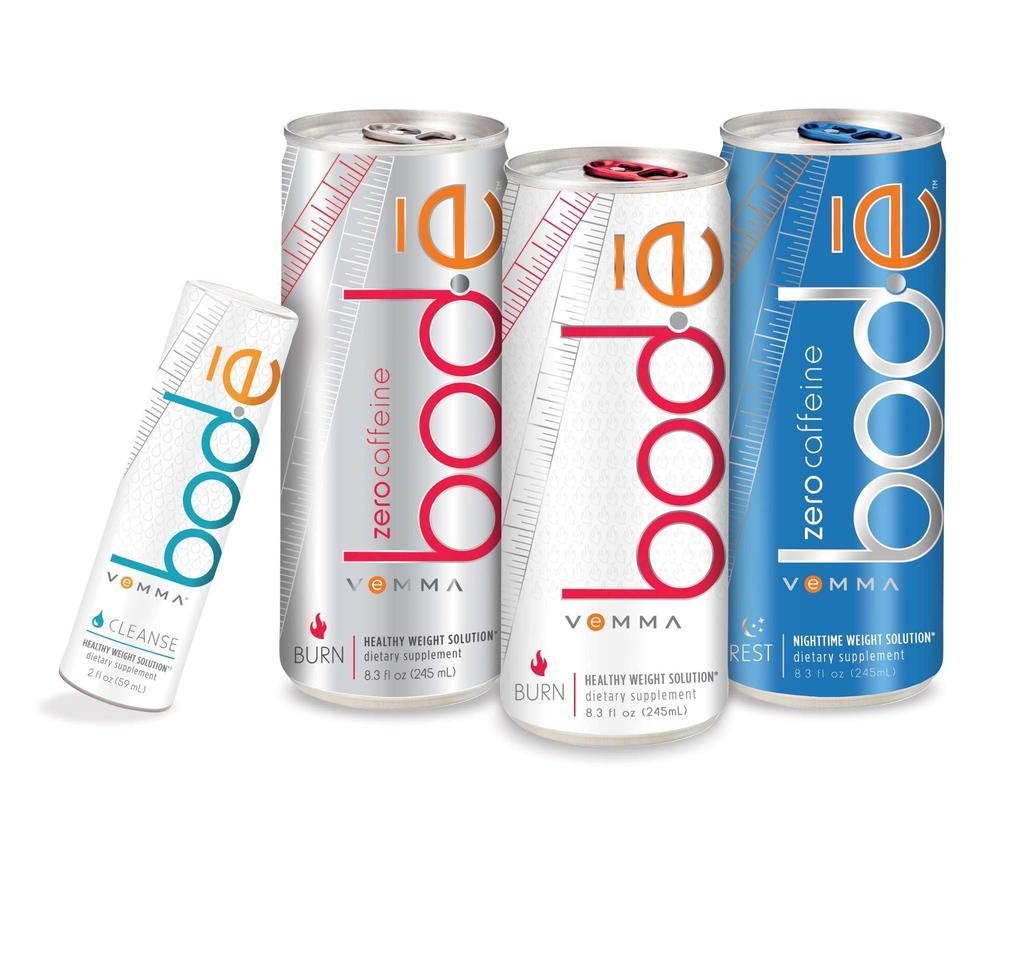<image>
Present a compact description of the photo's key features. 4 cans of a dietary supplements drink called bode 